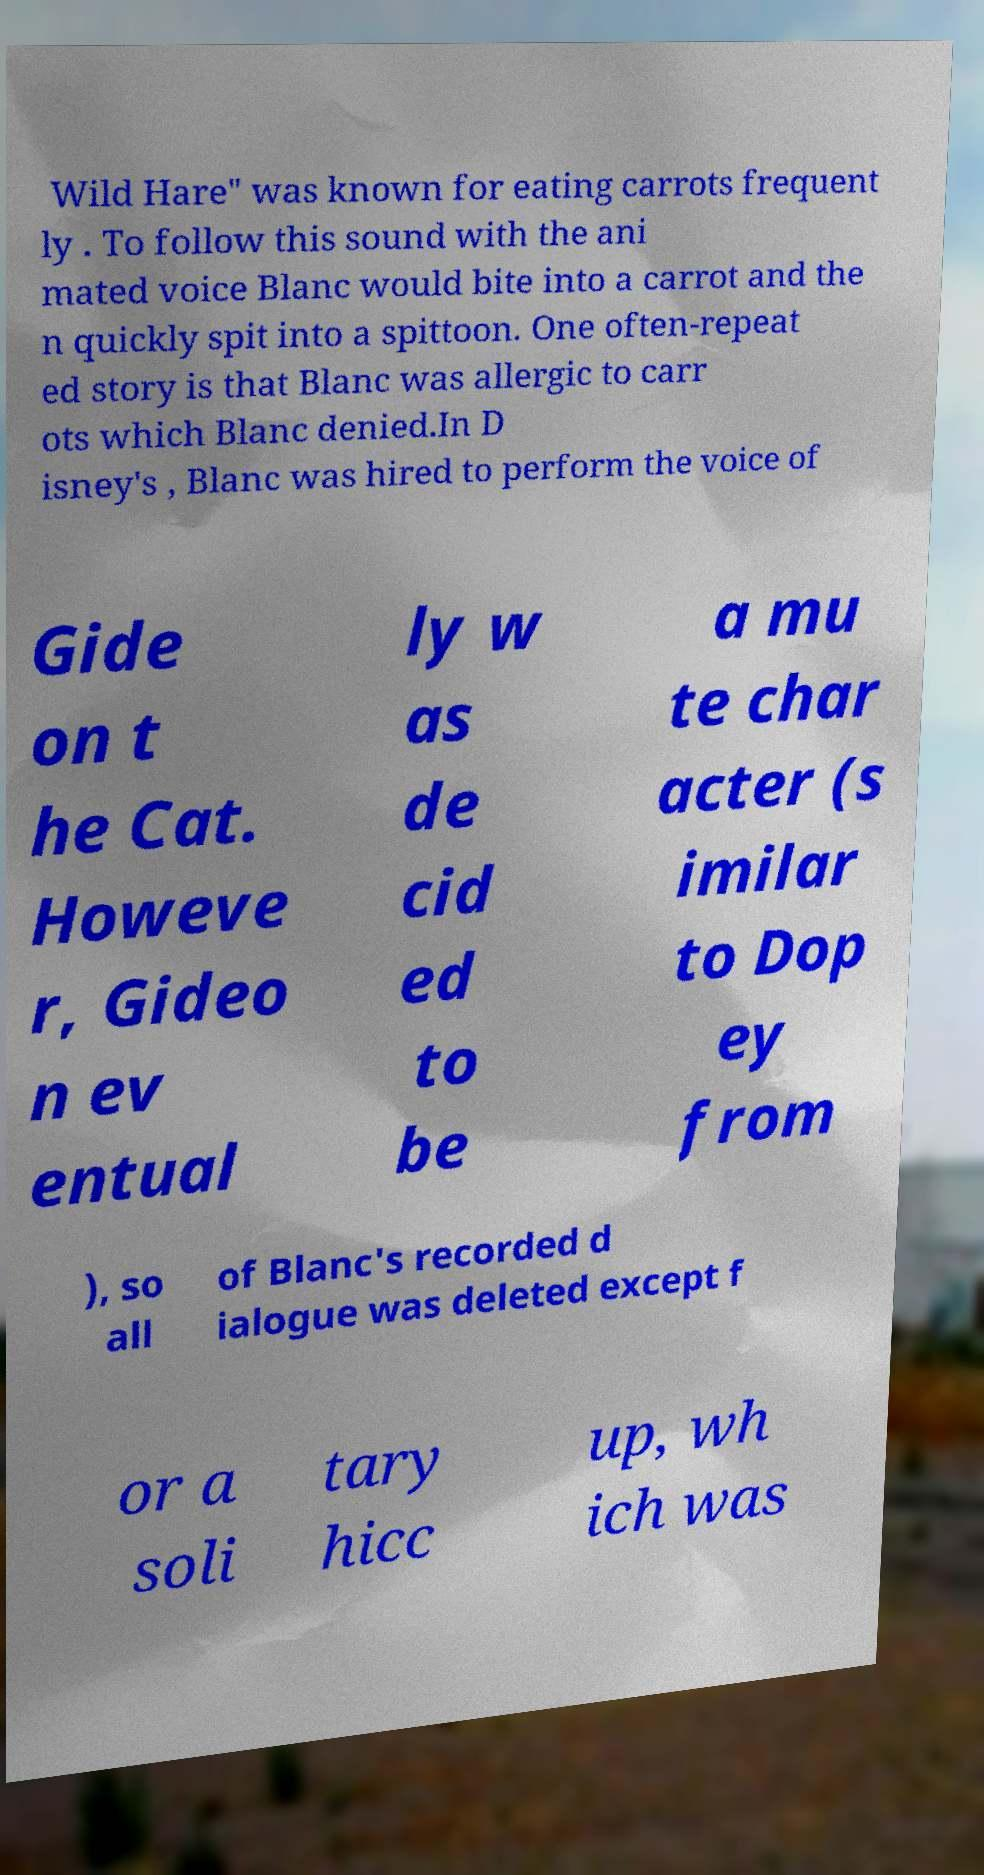There's text embedded in this image that I need extracted. Can you transcribe it verbatim? Wild Hare" was known for eating carrots frequent ly . To follow this sound with the ani mated voice Blanc would bite into a carrot and the n quickly spit into a spittoon. One often-repeat ed story is that Blanc was allergic to carr ots which Blanc denied.In D isney's , Blanc was hired to perform the voice of Gide on t he Cat. Howeve r, Gideo n ev entual ly w as de cid ed to be a mu te char acter (s imilar to Dop ey from ), so all of Blanc's recorded d ialogue was deleted except f or a soli tary hicc up, wh ich was 